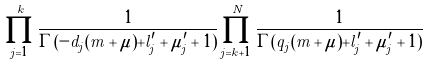<formula> <loc_0><loc_0><loc_500><loc_500>\prod _ { j = 1 } ^ { k } \frac { 1 } { \Gamma ( - d _ { j } ( m + \mu ) + l _ { j } ^ { \prime } + \mu _ { j } ^ { \prime } + 1 ) } \prod _ { j = k + 1 } ^ { N } \frac { 1 } { \Gamma ( q _ { j } ( m + \mu ) + l _ { j } ^ { \prime } + \mu _ { j } ^ { \prime } + 1 ) }</formula> 